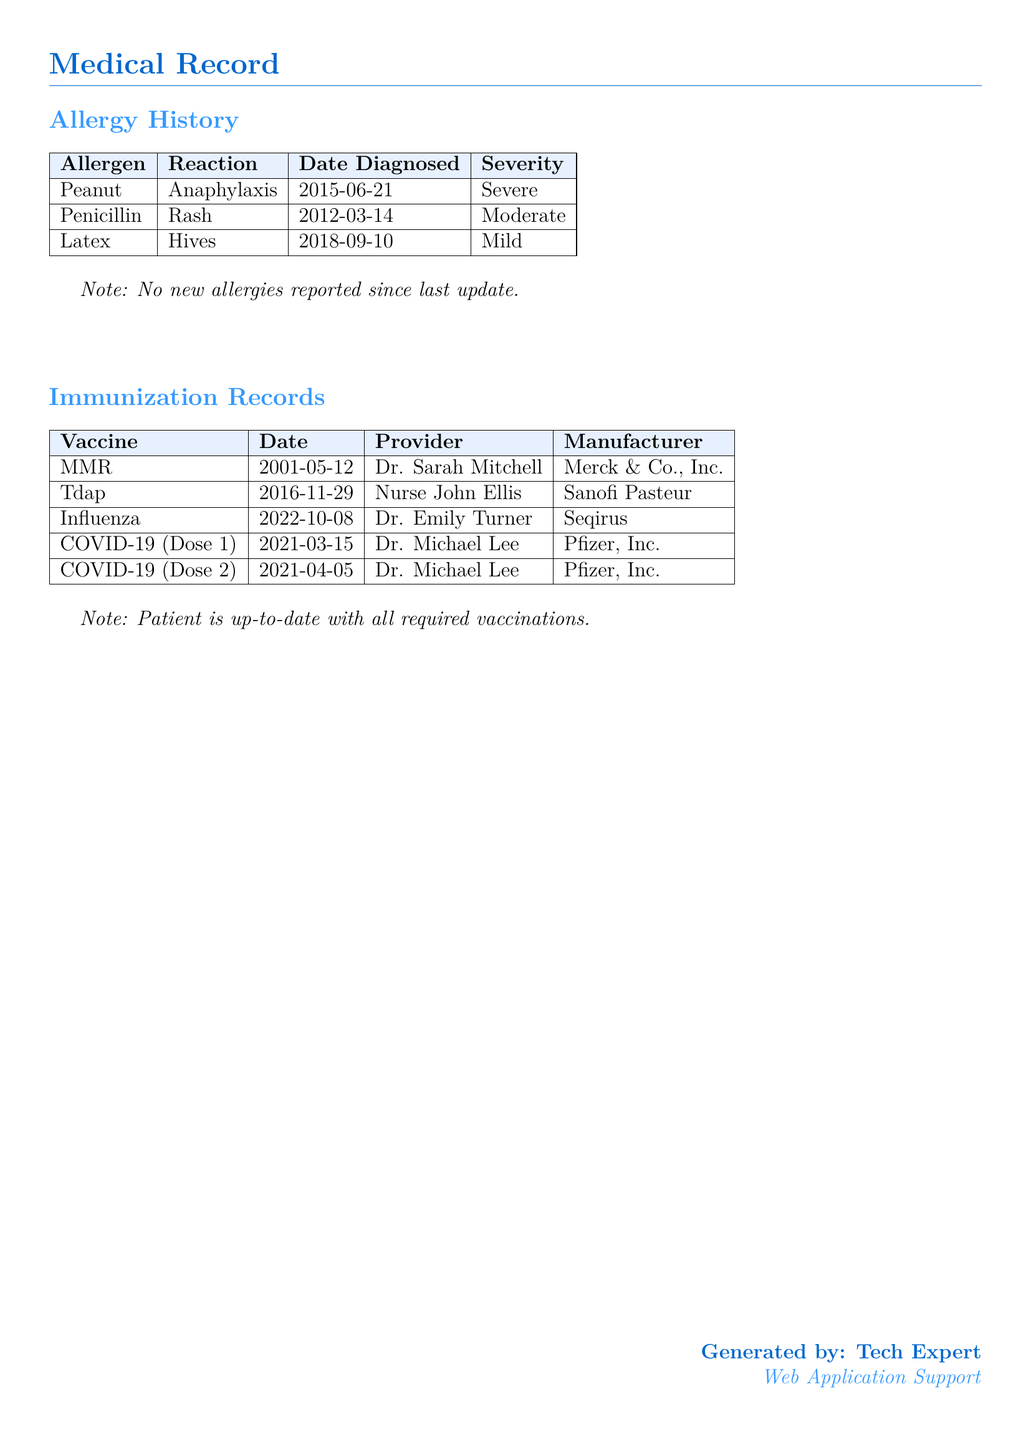What is the patient's allergy to peanuts? The document states that the patient experiences anaphylaxis when exposed to peanuts.
Answer: Anaphylaxis When was the latex allergy diagnosed? The document indicates that the latex allergy was diagnosed on September 10, 2018.
Answer: 2018-09-10 Which vaccine was administered on November 29, 2016? The document lists Tdap as the vaccine given on that date.
Answer: Tdap How many doses of the COVID-19 vaccine were administered? The document records two doses of the COVID-19 vaccine were administered.
Answer: 2 What is the severity of the penicillin allergy? According to the document, the reaction to penicillin is categorized as moderate.
Answer: Moderate Who administered the influenza vaccine? The document specifies that Dr. Emily Turner was the provider for the influenza vaccine.
Answer: Dr. Emily Turner What type of records are included in this document? The document includes the patient's allergy history and immunization records.
Answer: Allergy history and immunization records What is the manufacturer of the MMR vaccine? The document states that the MMR vaccine is manufactured by Merck & Co., Inc.
Answer: Merck & Co., Inc How does the patient’s immunization status appear? The document notes that the patient is up-to-date with all required vaccinations.
Answer: Up-to-date 